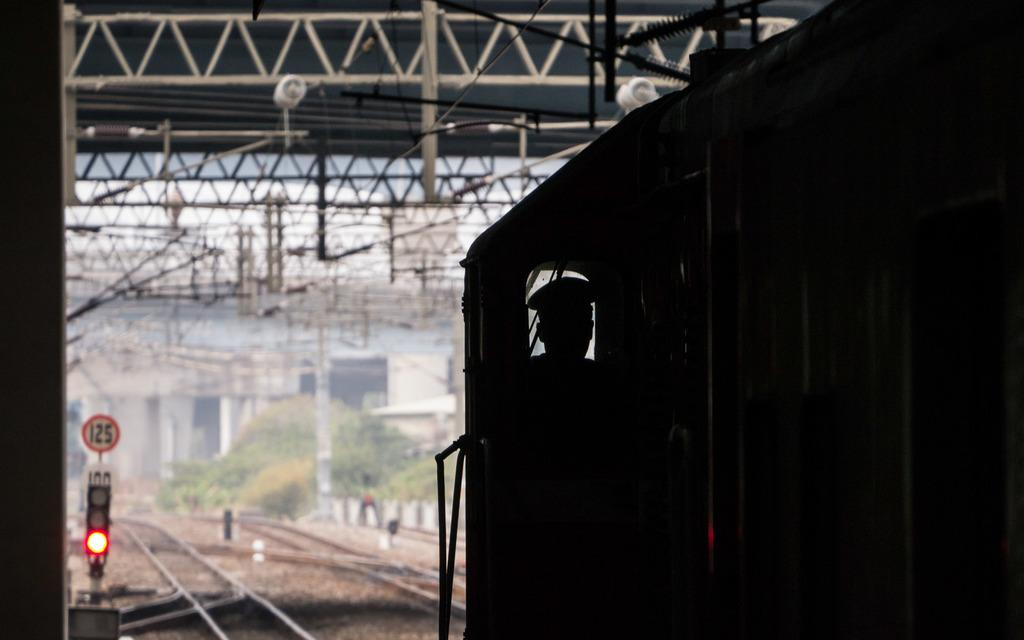What is the man in the image doing? The man is driving a train in the image. What can be seen at the bottom of the image? There are tracks at the bottom of the image. What is located to the left of the image? There is a signal pole to the left of the image. What is present at the top of the image? There are stands and wires at the top of the image. What type of beef is being served on the train in the image? There is no beef present in the image; it is a train with a driver and various infrastructure elements. 